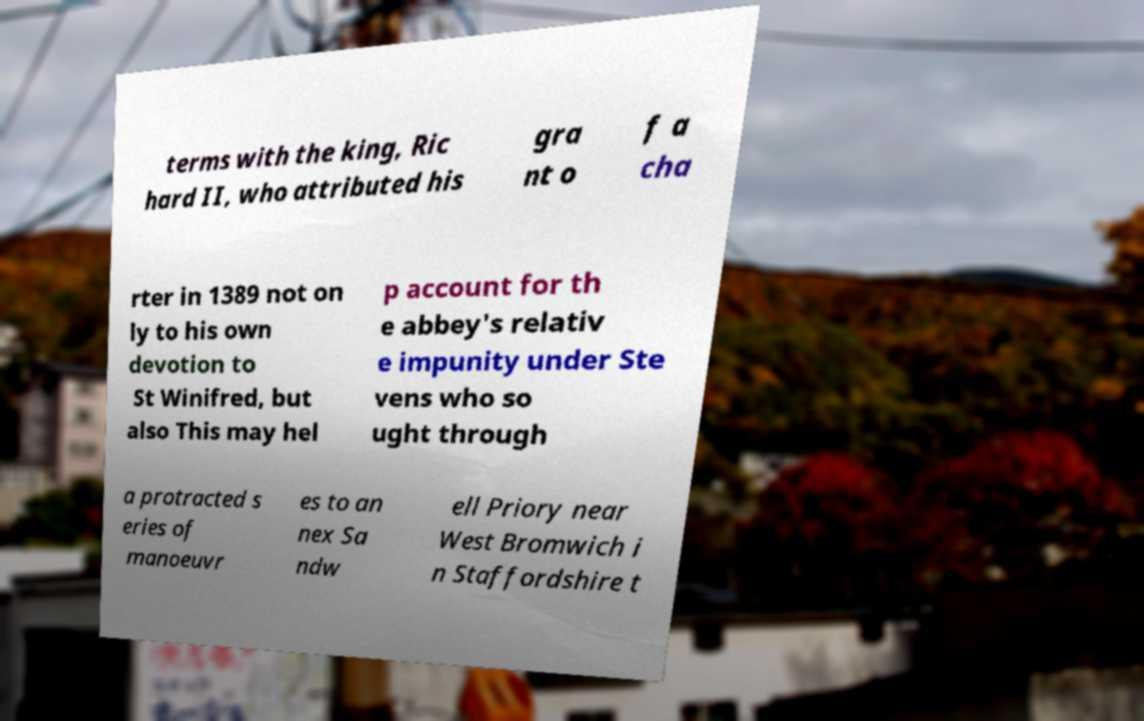Can you accurately transcribe the text from the provided image for me? terms with the king, Ric hard II, who attributed his gra nt o f a cha rter in 1389 not on ly to his own devotion to St Winifred, but also This may hel p account for th e abbey's relativ e impunity under Ste vens who so ught through a protracted s eries of manoeuvr es to an nex Sa ndw ell Priory near West Bromwich i n Staffordshire t 